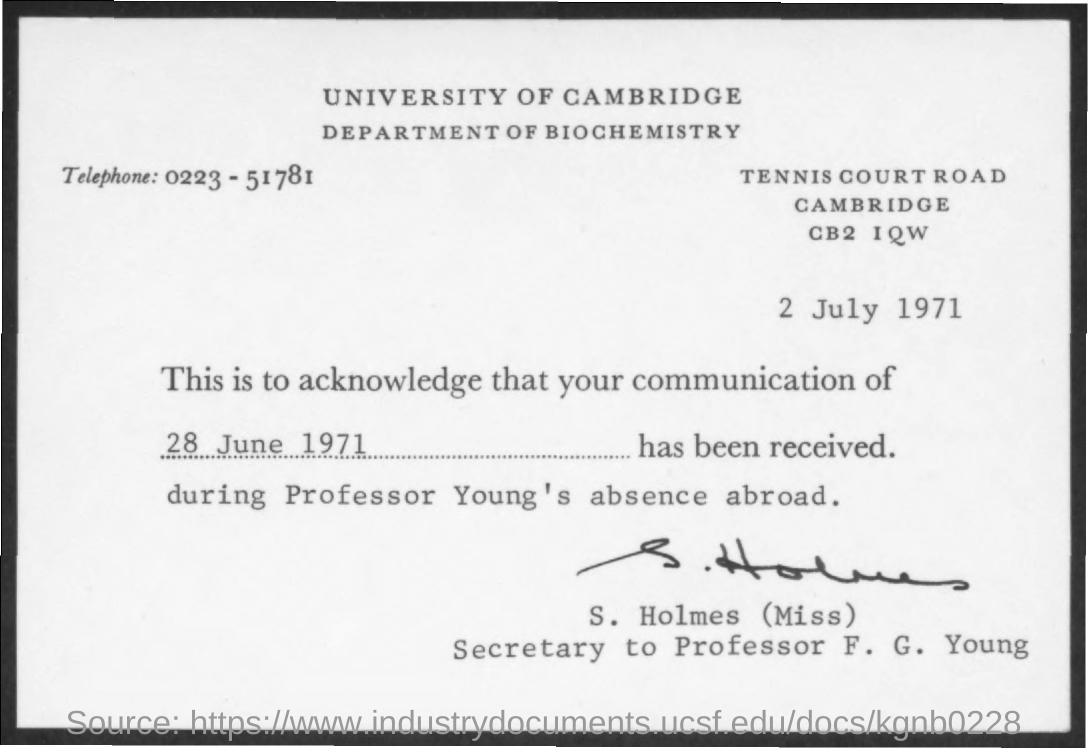Give some essential details in this illustration. The letter is from S. Holmes. The date on the document is 2 July 1971. The telephone is a device that is used to communicate through voice and text messages over a network of electronic switches and cables. 